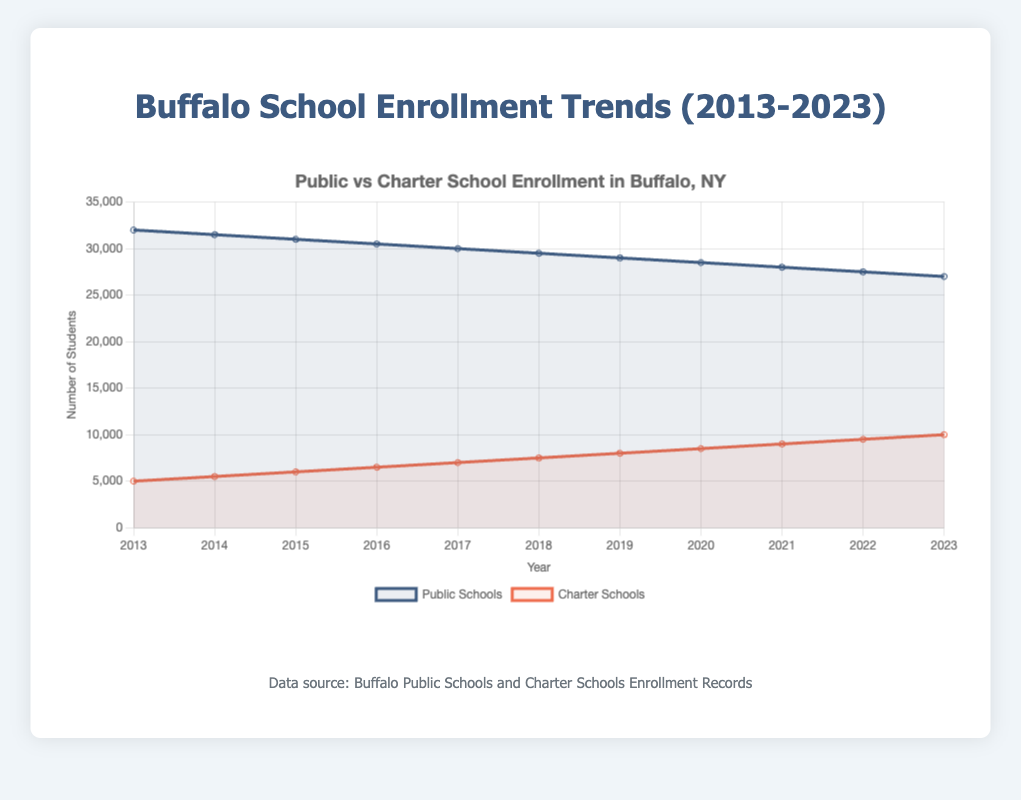What is the total enrollment in public and charter schools for the year 2023? For 2023, add the enrollment of public schools (27000) and charter schools (10000). 27000 + 10000 = 37000
Answer: 37000 In which year did the enrollment in charter schools reach 8000 students? Looking at the charter schools' enrollment curve, the enrollment reached 8000 in 2019.
Answer: 2019 What is the difference between public and charter school enrollments in 2017? Subtract the charter schools' enrollment in 2017 (7000) from the public schools' enrollment in the same year (30000). 30000 - 7000 = 23000
Answer: 23000 How did the enrollment in public schools change from 2013 to 2023? Subtract the public schools' enrollment in 2023 (27000) from that in 2013 (32000). 32000 - 27000 = 5000, indicating a decrease of 5000 students.
Answer: Decreased by 5000 students Which school type experienced a more significant enrollment increase over the decade? Compare the enrollment increase: public schools had a decrease from 32000 to 27000 (5000 decrease), whereas charter schools increased from 5000 to 10000 (5000 increase). Charter schools experienced a more significant relative increase.
Answer: Charter schools What is the average annual enrollment for charter schools between 2013 and 2023? Sum the charter schools' enrollments from 2013 to 2023 (5000 + 5500 + 6000 + 6500 + 7000 + 7500 + 8000 + 8500 + 9000 + 9500 + 10000 = 79000), then divide by the number of years (11). 79000 / 11 = 7181.82 students
Answer: 7181.82 students In which year did public schools have the lowest enrollment, and what was the count? Check the curve for public schools and note the lowest point, which is in 2023 with 27000 students.
Answer: 2023, 27000 students How much did charter school enrollment grow from 2013 to 2015? Subtract the charter schools' enrollment in 2013 (5000) from the enrollment in 2015 (6000). 6000 - 5000 = 1000
Answer: Increased by 1000 students Compare the rates of decline/increase in enrollments for public and charter schools from 2020 to 2023. For public schools: subtract 2023's enrollment (27000) from 2020's enrollment (28500). 28500 - 27000 = 1500 (decline). For charter schools: subtract 2020's enrollment (8500) from 2023's enrollment (10000). 10000 - 8500 = 1500 (increase). Both changed by 1500.
Answer: Same rate of 1500 What is the trend in charter school enrollment from 2018 to 2023? The enrollment in charter schools increased each year from 7500 in 2018 to 10000 in 2023, indicating a steady upward trend.
Answer: Steady increase 